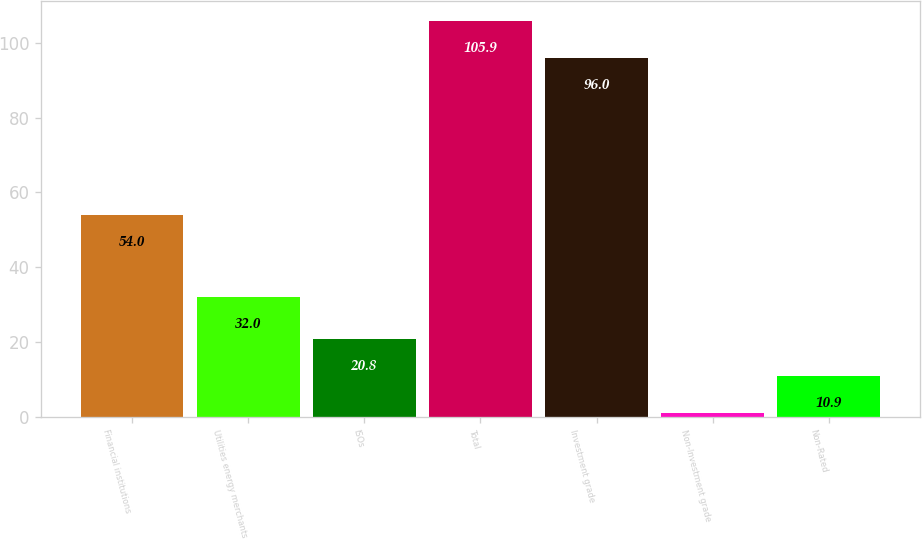<chart> <loc_0><loc_0><loc_500><loc_500><bar_chart><fcel>Financial institutions<fcel>Utilities energy merchants<fcel>ISOs<fcel>Total<fcel>Investment grade<fcel>Non-Investment grade<fcel>Non-Rated<nl><fcel>54<fcel>32<fcel>20.8<fcel>105.9<fcel>96<fcel>1<fcel>10.9<nl></chart> 